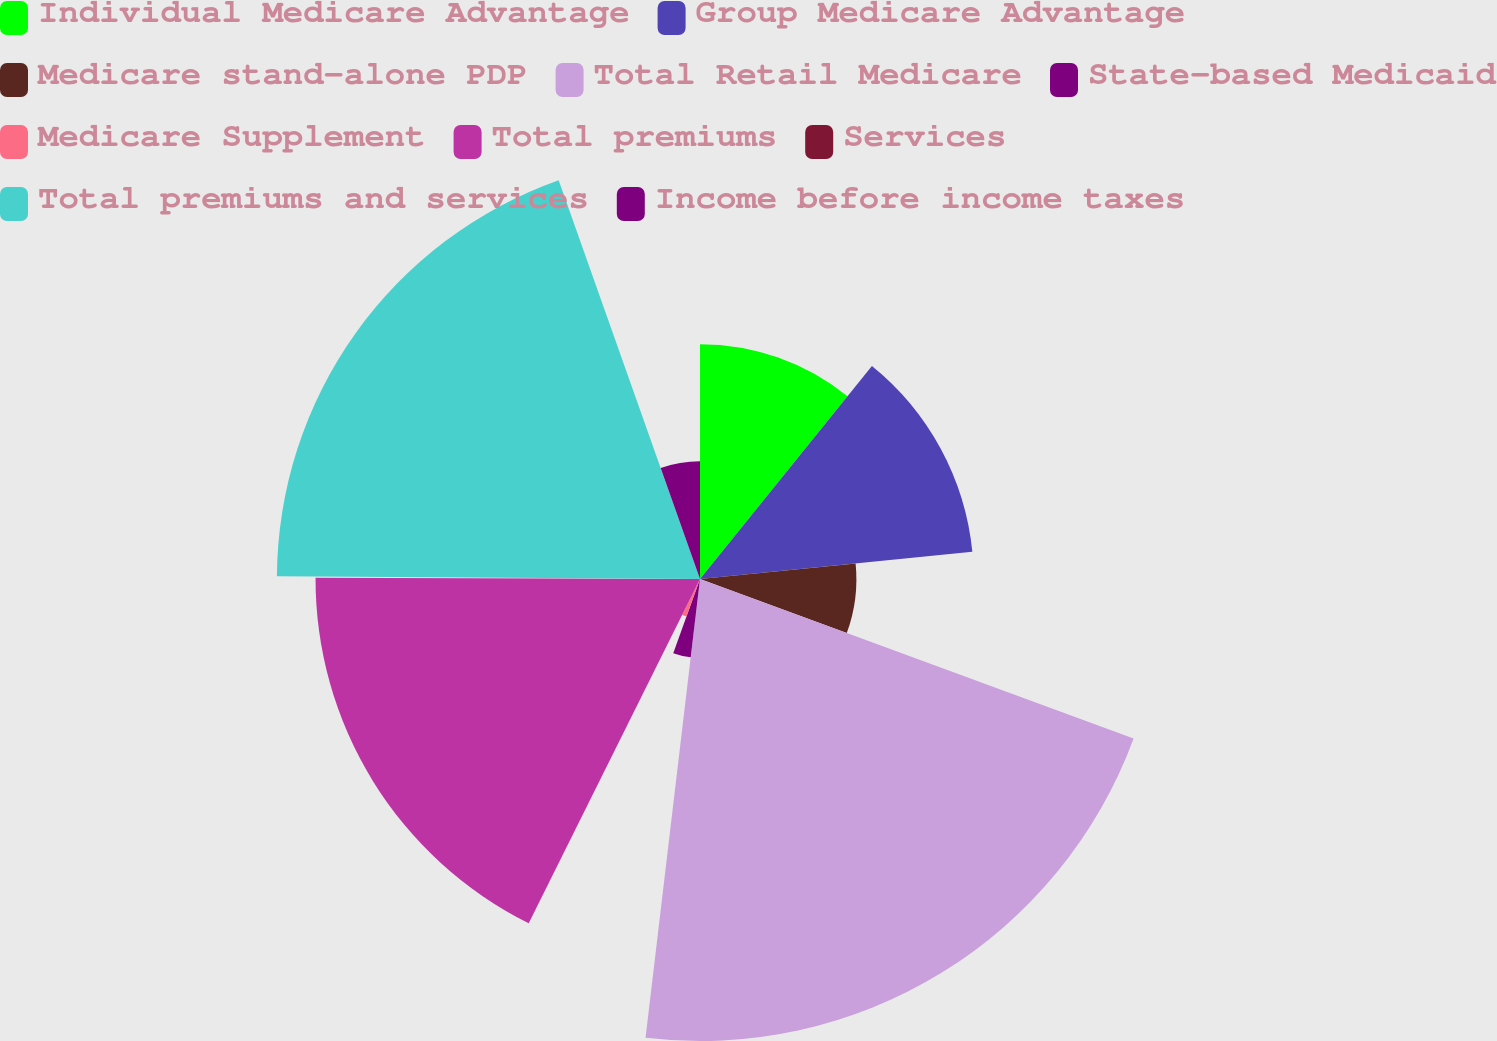<chart> <loc_0><loc_0><loc_500><loc_500><pie_chart><fcel>Individual Medicare Advantage<fcel>Group Medicare Advantage<fcel>Medicare stand-alone PDP<fcel>Total Retail Medicare<fcel>State-based Medicaid<fcel>Medicare Supplement<fcel>Total premiums<fcel>Services<fcel>Total premiums and services<fcel>Income before income taxes<nl><fcel>10.81%<fcel>12.6%<fcel>7.2%<fcel>21.27%<fcel>3.63%<fcel>1.84%<fcel>17.7%<fcel>0.05%<fcel>19.48%<fcel>5.42%<nl></chart> 